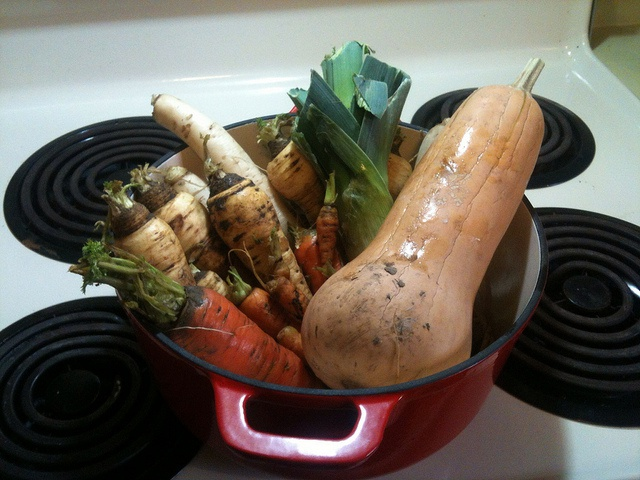Describe the objects in this image and their specific colors. I can see oven in black, lightgray, maroon, olive, and darkgray tones, bowl in gray, black, maroon, olive, and brown tones, carrot in gray, black, maroon, darkgreen, and brown tones, carrot in gray, black, maroon, and tan tones, and carrot in gray, black, tan, and olive tones in this image. 